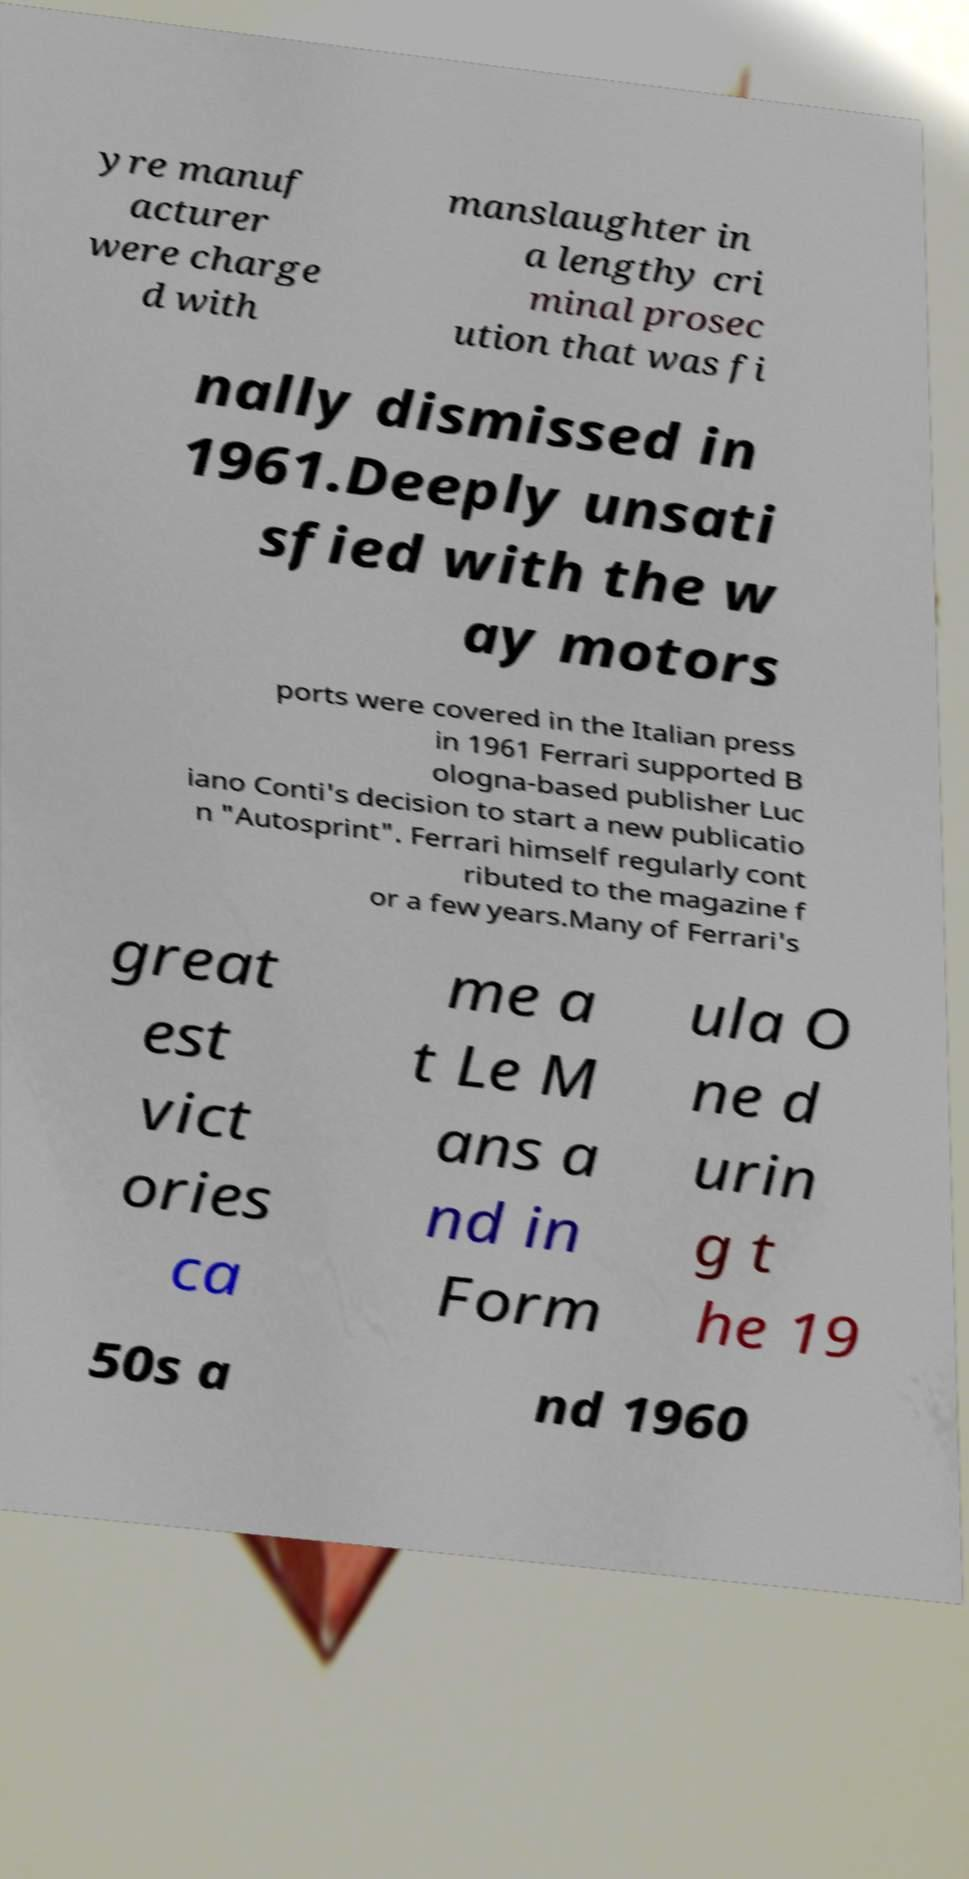Can you accurately transcribe the text from the provided image for me? yre manuf acturer were charge d with manslaughter in a lengthy cri minal prosec ution that was fi nally dismissed in 1961.Deeply unsati sfied with the w ay motors ports were covered in the Italian press in 1961 Ferrari supported B ologna-based publisher Luc iano Conti's decision to start a new publicatio n "Autosprint". Ferrari himself regularly cont ributed to the magazine f or a few years.Many of Ferrari's great est vict ories ca me a t Le M ans a nd in Form ula O ne d urin g t he 19 50s a nd 1960 